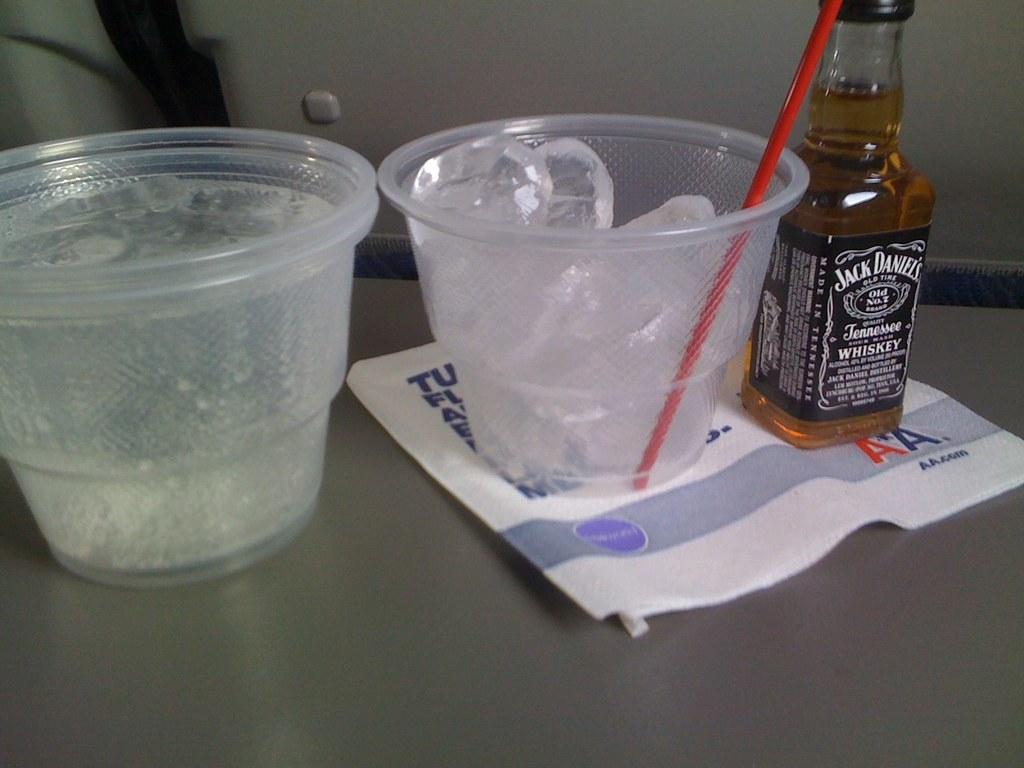Provide a one-sentence caption for the provided image. A small bottle of Jack Daniels sits beside a small cup with only ice and another cup filled with clear liquid. 